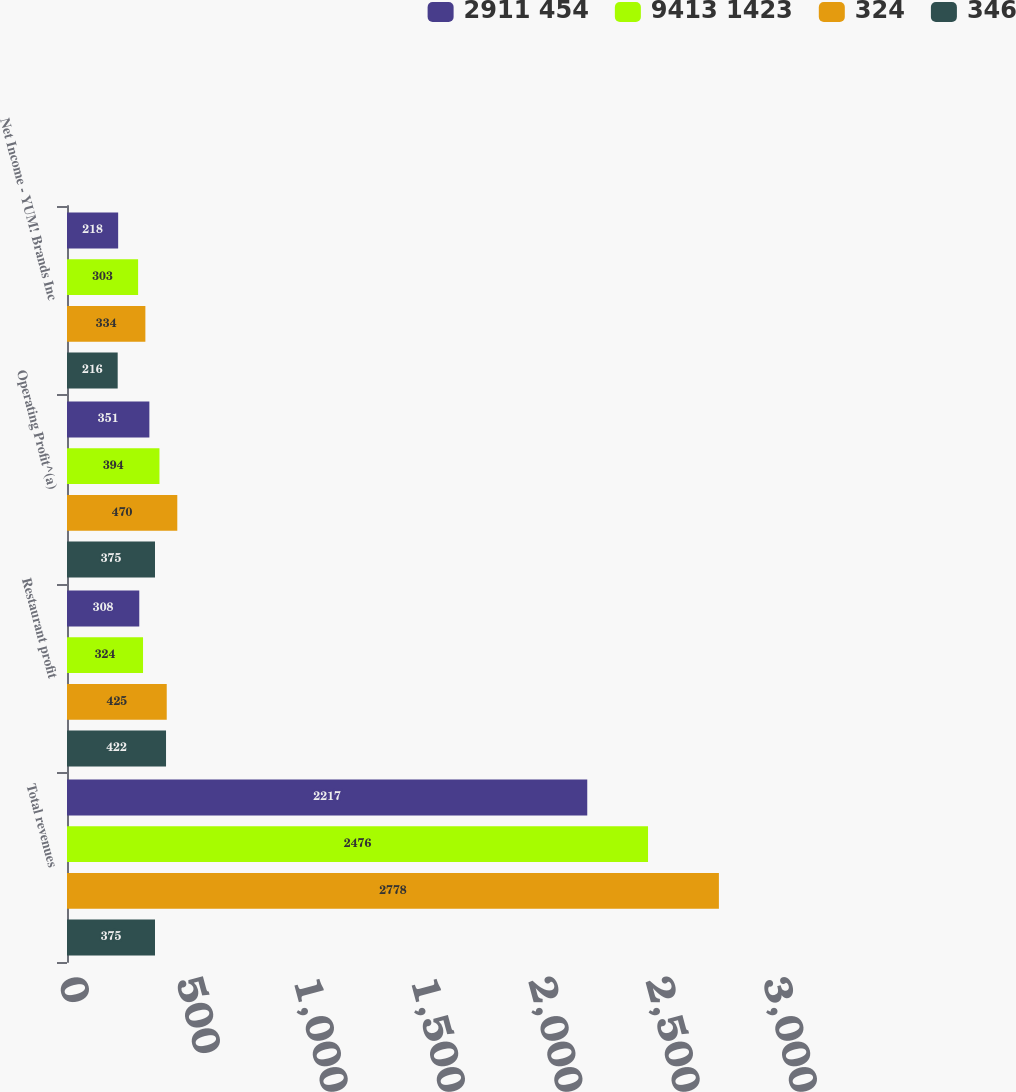<chart> <loc_0><loc_0><loc_500><loc_500><stacked_bar_chart><ecel><fcel>Total revenues<fcel>Restaurant profit<fcel>Operating Profit^(a)<fcel>Net Income - YUM! Brands Inc<nl><fcel>2911 454<fcel>2217<fcel>308<fcel>351<fcel>218<nl><fcel>9413 1423<fcel>2476<fcel>324<fcel>394<fcel>303<nl><fcel>324<fcel>2778<fcel>425<fcel>470<fcel>334<nl><fcel>346<fcel>375<fcel>422<fcel>375<fcel>216<nl></chart> 